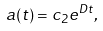<formula> <loc_0><loc_0><loc_500><loc_500>a ( t ) = c _ { 2 } e ^ { D t } ,</formula> 